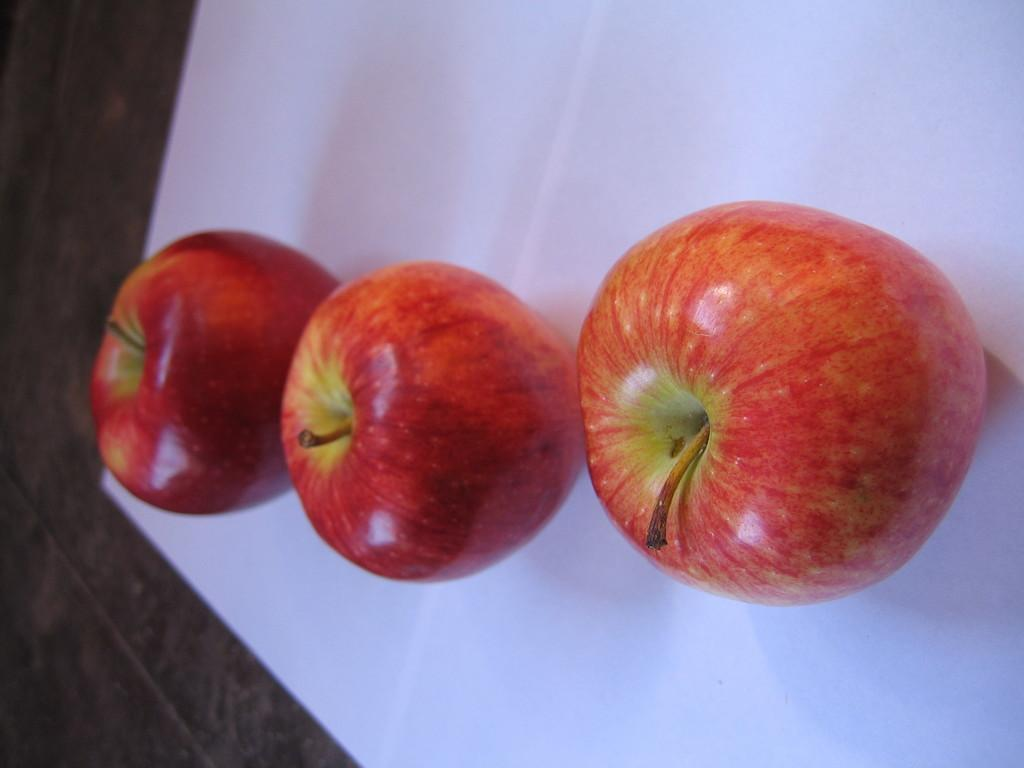What type of food items are present in the image? There are fruits in the image. Where are the fruits located? The fruits are on a surface. What is the color of the surface? The surface is white in color. Can you see a receipt for the fruits in the image? There is no receipt present in the image; it only shows fruits on a white surface. 